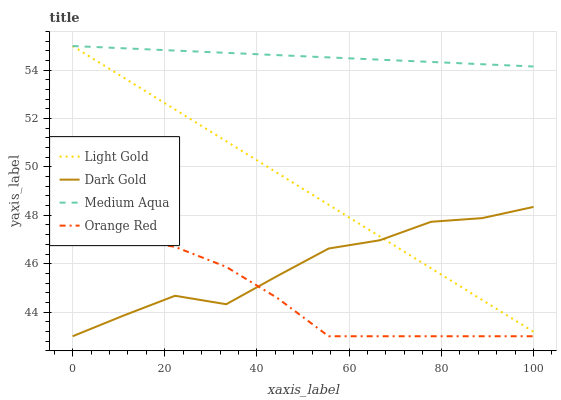Does Orange Red have the minimum area under the curve?
Answer yes or no. Yes. Does Medium Aqua have the maximum area under the curve?
Answer yes or no. Yes. Does Light Gold have the minimum area under the curve?
Answer yes or no. No. Does Light Gold have the maximum area under the curve?
Answer yes or no. No. Is Light Gold the smoothest?
Answer yes or no. Yes. Is Dark Gold the roughest?
Answer yes or no. Yes. Is Orange Red the smoothest?
Answer yes or no. No. Is Orange Red the roughest?
Answer yes or no. No. Does Orange Red have the lowest value?
Answer yes or no. Yes. Does Light Gold have the lowest value?
Answer yes or no. No. Does Light Gold have the highest value?
Answer yes or no. Yes. Does Orange Red have the highest value?
Answer yes or no. No. Is Orange Red less than Medium Aqua?
Answer yes or no. Yes. Is Light Gold greater than Orange Red?
Answer yes or no. Yes. Does Light Gold intersect Dark Gold?
Answer yes or no. Yes. Is Light Gold less than Dark Gold?
Answer yes or no. No. Is Light Gold greater than Dark Gold?
Answer yes or no. No. Does Orange Red intersect Medium Aqua?
Answer yes or no. No. 